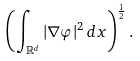Convert formula to latex. <formula><loc_0><loc_0><loc_500><loc_500>\left ( \int _ { \mathbb { R } ^ { d } } | \nabla \varphi | ^ { 2 } \, d x \right ) ^ { \frac { 1 } { 2 } } .</formula> 